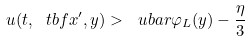Convert formula to latex. <formula><loc_0><loc_0><loc_500><loc_500>u ( t , \ t b f { x } ^ { \prime } , y ) > \ u b a r \varphi _ { L } ( y ) - \frac { \eta } { 3 }</formula> 